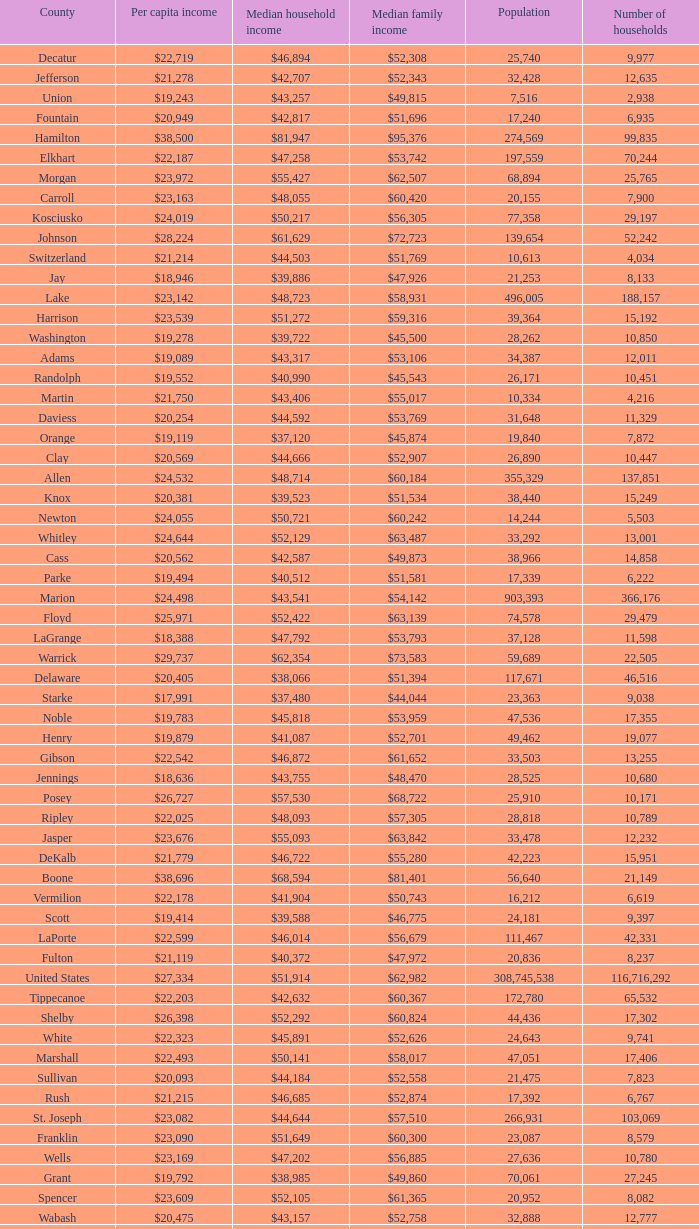What County has a Median household income of $46,872? Gibson. Could you help me parse every detail presented in this table? {'header': ['County', 'Per capita income', 'Median household income', 'Median family income', 'Population', 'Number of households'], 'rows': [['Decatur', '$22,719', '$46,894', '$52,308', '25,740', '9,977'], ['Jefferson', '$21,278', '$42,707', '$52,343', '32,428', '12,635'], ['Union', '$19,243', '$43,257', '$49,815', '7,516', '2,938'], ['Fountain', '$20,949', '$42,817', '$51,696', '17,240', '6,935'], ['Hamilton', '$38,500', '$81,947', '$95,376', '274,569', '99,835'], ['Elkhart', '$22,187', '$47,258', '$53,742', '197,559', '70,244'], ['Morgan', '$23,972', '$55,427', '$62,507', '68,894', '25,765'], ['Carroll', '$23,163', '$48,055', '$60,420', '20,155', '7,900'], ['Kosciusko', '$24,019', '$50,217', '$56,305', '77,358', '29,197'], ['Johnson', '$28,224', '$61,629', '$72,723', '139,654', '52,242'], ['Switzerland', '$21,214', '$44,503', '$51,769', '10,613', '4,034'], ['Jay', '$18,946', '$39,886', '$47,926', '21,253', '8,133'], ['Lake', '$23,142', '$48,723', '$58,931', '496,005', '188,157'], ['Harrison', '$23,539', '$51,272', '$59,316', '39,364', '15,192'], ['Washington', '$19,278', '$39,722', '$45,500', '28,262', '10,850'], ['Adams', '$19,089', '$43,317', '$53,106', '34,387', '12,011'], ['Randolph', '$19,552', '$40,990', '$45,543', '26,171', '10,451'], ['Martin', '$21,750', '$43,406', '$55,017', '10,334', '4,216'], ['Daviess', '$20,254', '$44,592', '$53,769', '31,648', '11,329'], ['Orange', '$19,119', '$37,120', '$45,874', '19,840', '7,872'], ['Clay', '$20,569', '$44,666', '$52,907', '26,890', '10,447'], ['Allen', '$24,532', '$48,714', '$60,184', '355,329', '137,851'], ['Knox', '$20,381', '$39,523', '$51,534', '38,440', '15,249'], ['Newton', '$24,055', '$50,721', '$60,242', '14,244', '5,503'], ['Whitley', '$24,644', '$52,129', '$63,487', '33,292', '13,001'], ['Cass', '$20,562', '$42,587', '$49,873', '38,966', '14,858'], ['Parke', '$19,494', '$40,512', '$51,581', '17,339', '6,222'], ['Marion', '$24,498', '$43,541', '$54,142', '903,393', '366,176'], ['Floyd', '$25,971', '$52,422', '$63,139', '74,578', '29,479'], ['LaGrange', '$18,388', '$47,792', '$53,793', '37,128', '11,598'], ['Warrick', '$29,737', '$62,354', '$73,583', '59,689', '22,505'], ['Delaware', '$20,405', '$38,066', '$51,394', '117,671', '46,516'], ['Starke', '$17,991', '$37,480', '$44,044', '23,363', '9,038'], ['Noble', '$19,783', '$45,818', '$53,959', '47,536', '17,355'], ['Henry', '$19,879', '$41,087', '$52,701', '49,462', '19,077'], ['Gibson', '$22,542', '$46,872', '$61,652', '33,503', '13,255'], ['Jennings', '$18,636', '$43,755', '$48,470', '28,525', '10,680'], ['Posey', '$26,727', '$57,530', '$68,722', '25,910', '10,171'], ['Ripley', '$22,025', '$48,093', '$57,305', '28,818', '10,789'], ['Jasper', '$23,676', '$55,093', '$63,842', '33,478', '12,232'], ['DeKalb', '$21,779', '$46,722', '$55,280', '42,223', '15,951'], ['Boone', '$38,696', '$68,594', '$81,401', '56,640', '21,149'], ['Vermilion', '$22,178', '$41,904', '$50,743', '16,212', '6,619'], ['Scott', '$19,414', '$39,588', '$46,775', '24,181', '9,397'], ['LaPorte', '$22,599', '$46,014', '$56,679', '111,467', '42,331'], ['Fulton', '$21,119', '$40,372', '$47,972', '20,836', '8,237'], ['United States', '$27,334', '$51,914', '$62,982', '308,745,538', '116,716,292'], ['Tippecanoe', '$22,203', '$42,632', '$60,367', '172,780', '65,532'], ['Shelby', '$26,398', '$52,292', '$60,824', '44,436', '17,302'], ['White', '$22,323', '$45,891', '$52,626', '24,643', '9,741'], ['Marshall', '$22,493', '$50,141', '$58,017', '47,051', '17,406'], ['Sullivan', '$20,093', '$44,184', '$52,558', '21,475', '7,823'], ['Rush', '$21,215', '$46,685', '$52,874', '17,392', '6,767'], ['St. Joseph', '$23,082', '$44,644', '$57,510', '266,931', '103,069'], ['Franklin', '$23,090', '$51,649', '$60,300', '23,087', '8,579'], ['Wells', '$23,169', '$47,202', '$56,885', '27,636', '10,780'], ['Grant', '$19,792', '$38,985', '$49,860', '70,061', '27,245'], ['Spencer', '$23,609', '$52,105', '$61,365', '20,952', '8,082'], ['Wabash', '$20,475', '$43,157', '$52,758', '32,888', '12,777'], ['Clinton', '$21,131', '$48,416', '$57,445', '33,224', '12,105'], ['Pulaski', '$20,491', '$44,016', '$50,903', '13,402', '5,282'], ['Greene', '$20,676', '$41,103', '$50,740', '33,165', '13,487'], ['Miami', '$18,854', '$39,485', '$49,282', '36,903', '13,456'], ['Lawrence', '$21,352', '$40,380', '$50,355', '46,134', '18,811'], ['Tipton', '$23,499', '$51,485', '$61,115', '15,936', '6,376'], ['Owen', '$20,581', '$44,285', '$52,343', '21,575', '8,486'], ['Brown', '$24,312', '$50,139', '$56,911', '15,242', '6,199'], ['Benton', '$21,949', '$46,318', '$58,661', '8,854', '3,479'], ['Monroe', '$21,882', '$38,137', '$60,845', '137,974', '54,864'], ['Crawford', '$18,598', '$37,988', '$46,073', '10,713', '4,303'], ['Vanderburgh', '$23,945', '$42,396', '$57,076', '179,703', '74,454'], ['Howard', '$23,759', '$45,003', '$55,479', '82,752', '34,301'], ['Madison', '$21,722', '$43,256', '$53,906', '131,636', '51,927'], ['Dubois', '$24,801', '$52,871', '$64,286', '41,889', '16,133'], ['Warren', '$23,670', '$49,238', '$57,990', '8,508', '3,337'], ['Huntington', '$21,575', '$45,964', '$55,630', '37,124', '14,218'], ['Pike', '$20,005', '$41,222', '$49,423', '12,845', '5,186'], ['Porter', '$27,922', '$60,889', '$73,065', '164,343', '61,998'], ['Blackford', '$21,783', '$41,989', '$47,287', '12,766', '5,236'], ['Indiana', '$24,058', '$47,697', '$58,944', '6,483,802', '2,502,154'], ['Ohio', '$25,703', '$50,966', '$64,271', '6,128', '2,477'], ['Dearborn', '$25,023', '$56,789', '$66,561', '50,047', '18,743'], ['Hendricks', '$28,880', '$67,180', '$77,397', '145,448', '52,368'], ['Jackson', '$21,498', '$43,980', '$53,534', '42,376', '16,501'], ['Montgomery', '$22,788', '$47,694', '$56,374', '38,124', '14,979'], ['Fayette', '$18,928', '$37,038', '$46,601', '24,277', '9,719'], ['Perry', '$20,806', '$45,108', '$55,497', '19,338', '7,476'], ['Steuben', '$22,950', '$47,479', '$57,154', '34,185', '13,310'], ['Clark', '$23,592', '$47,368', '$58,090', '110,232', '44,248'], ['Hancock', '$28,017', '$61,052', '$69,734', '70,002', '26,304'], ['Bartholomew', '$26,860', '$52,742', '$64,024', '76,794', '29,860'], ['Putnam', '$20,441', '$48,992', '$59,354', '37,963', '12,917'], ['Wayne', '$21,789', '$41,123', '$51,155', '68,917', '27,551'], ['Vigo', '$20,398', '$38,508', '$50,413', '107,848', '41,361']]} 